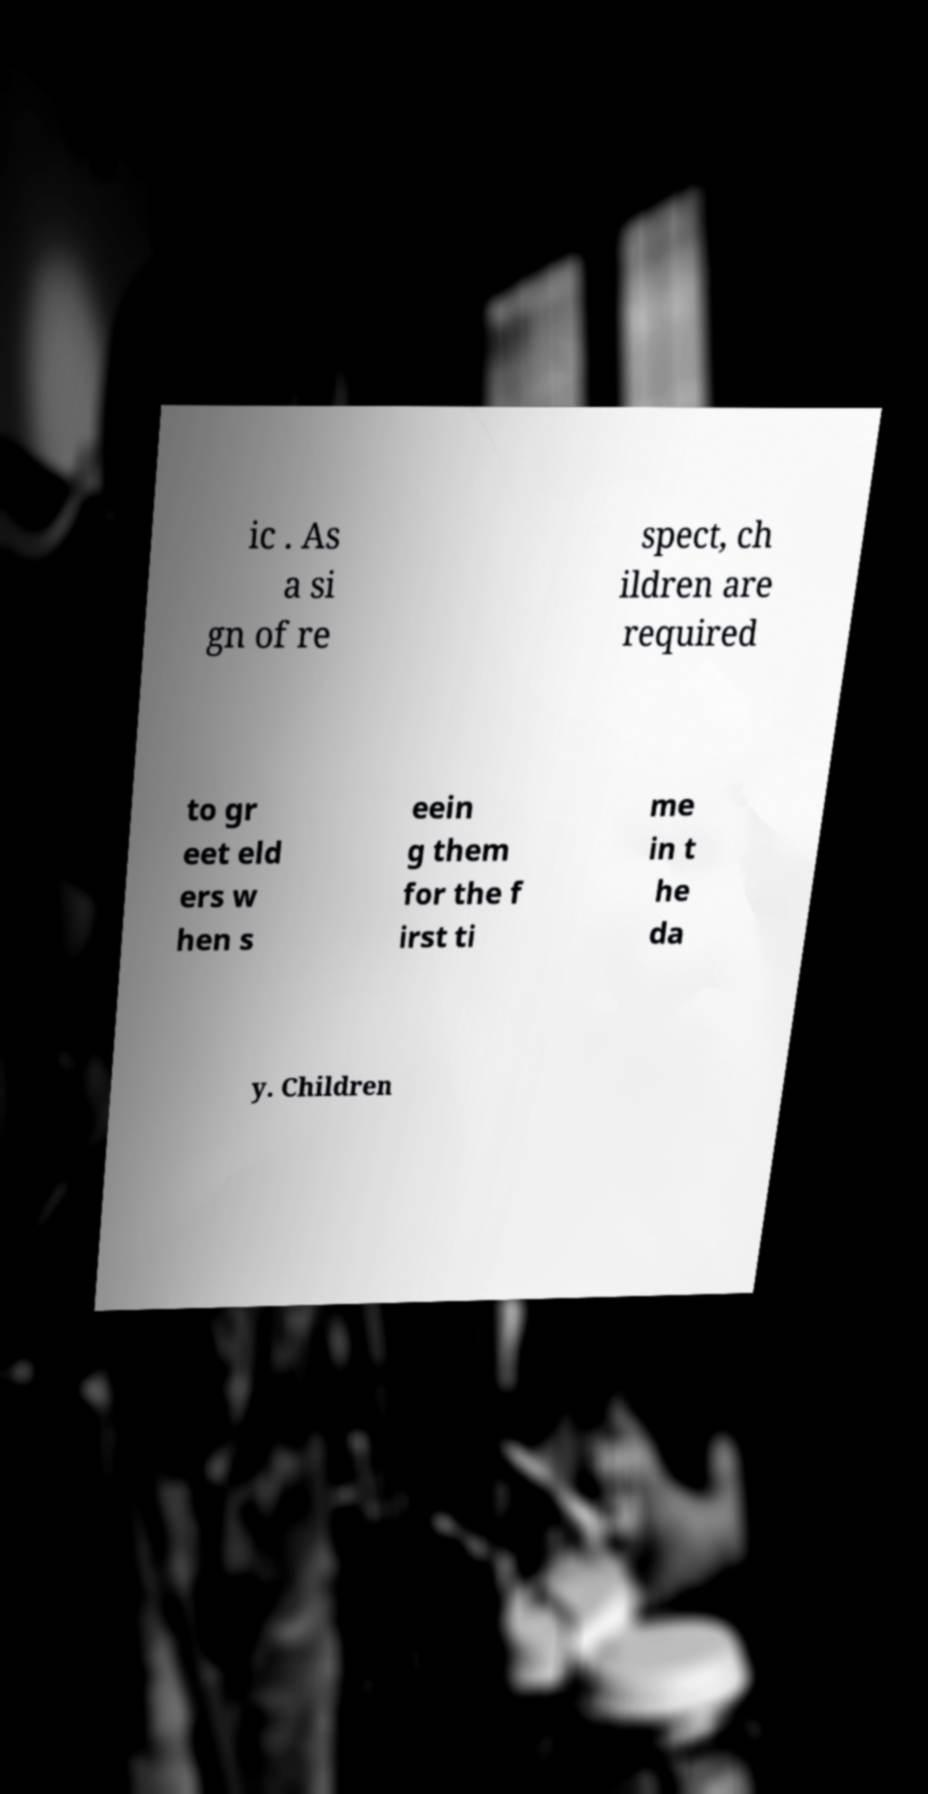Can you read and provide the text displayed in the image?This photo seems to have some interesting text. Can you extract and type it out for me? ic . As a si gn of re spect, ch ildren are required to gr eet eld ers w hen s eein g them for the f irst ti me in t he da y. Children 